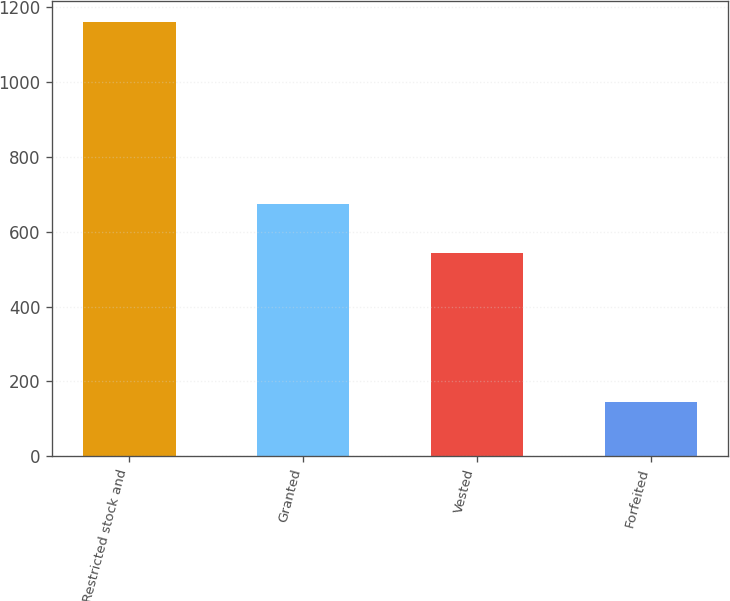<chart> <loc_0><loc_0><loc_500><loc_500><bar_chart><fcel>Restricted stock and<fcel>Granted<fcel>Vested<fcel>Forfeited<nl><fcel>1160<fcel>674<fcel>543<fcel>145<nl></chart> 